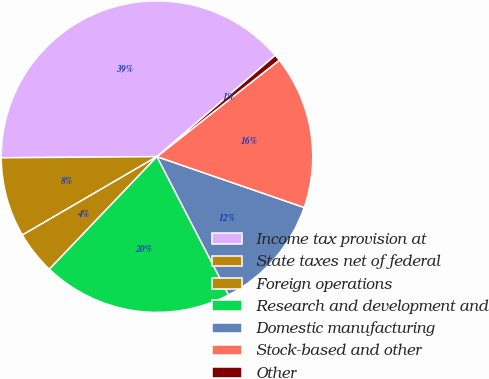Convert chart to OTSL. <chart><loc_0><loc_0><loc_500><loc_500><pie_chart><fcel>Income tax provision at<fcel>State taxes net of federal<fcel>Foreign operations<fcel>Research and development and<fcel>Domestic manufacturing<fcel>Stock-based and other<fcel>Other<nl><fcel>38.84%<fcel>8.28%<fcel>4.46%<fcel>19.74%<fcel>12.1%<fcel>15.92%<fcel>0.64%<nl></chart> 